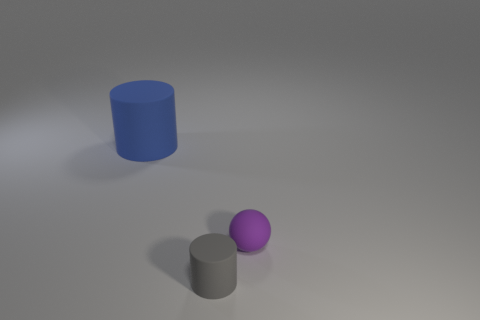Subtract all balls. How many objects are left? 2 Add 1 tiny purple shiny blocks. How many objects exist? 4 Subtract 1 balls. How many balls are left? 0 Subtract 1 purple spheres. How many objects are left? 2 Subtract all red spheres. Subtract all yellow blocks. How many spheres are left? 1 Subtract all green matte spheres. Subtract all large rubber cylinders. How many objects are left? 2 Add 3 large matte objects. How many large matte objects are left? 4 Add 1 small red cylinders. How many small red cylinders exist? 1 